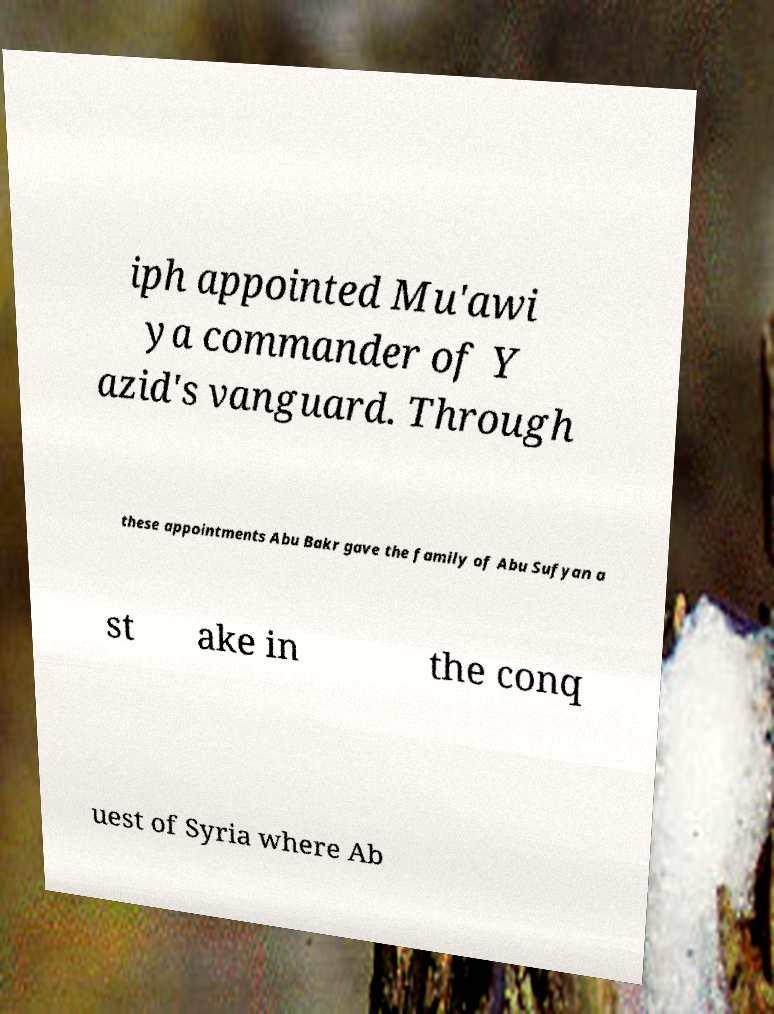Could you assist in decoding the text presented in this image and type it out clearly? iph appointed Mu'awi ya commander of Y azid's vanguard. Through these appointments Abu Bakr gave the family of Abu Sufyan a st ake in the conq uest of Syria where Ab 